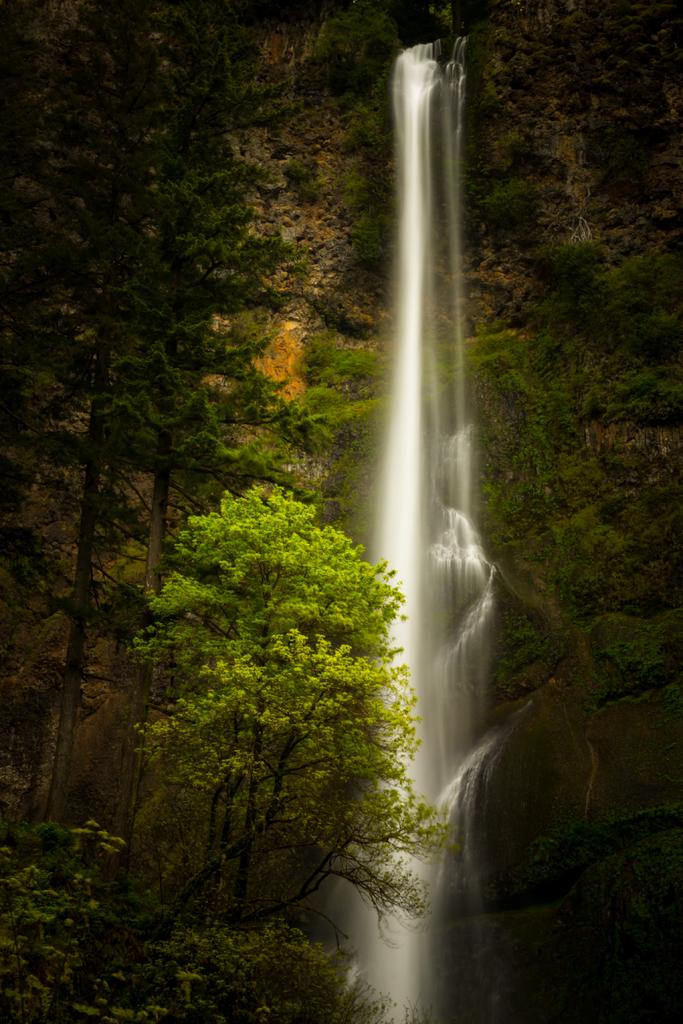What natural feature is the main subject of the image? There is a waterfall in the image. What type of vegetation is present near the waterfall? There are trees beside the waterfall. What other geological features are visible near the waterfall? There are rocks beside the waterfall. Can you see any metal structures near the waterfall in the image? There is no mention of any metal structures in the image; it features a waterfall, trees, and rocks. 